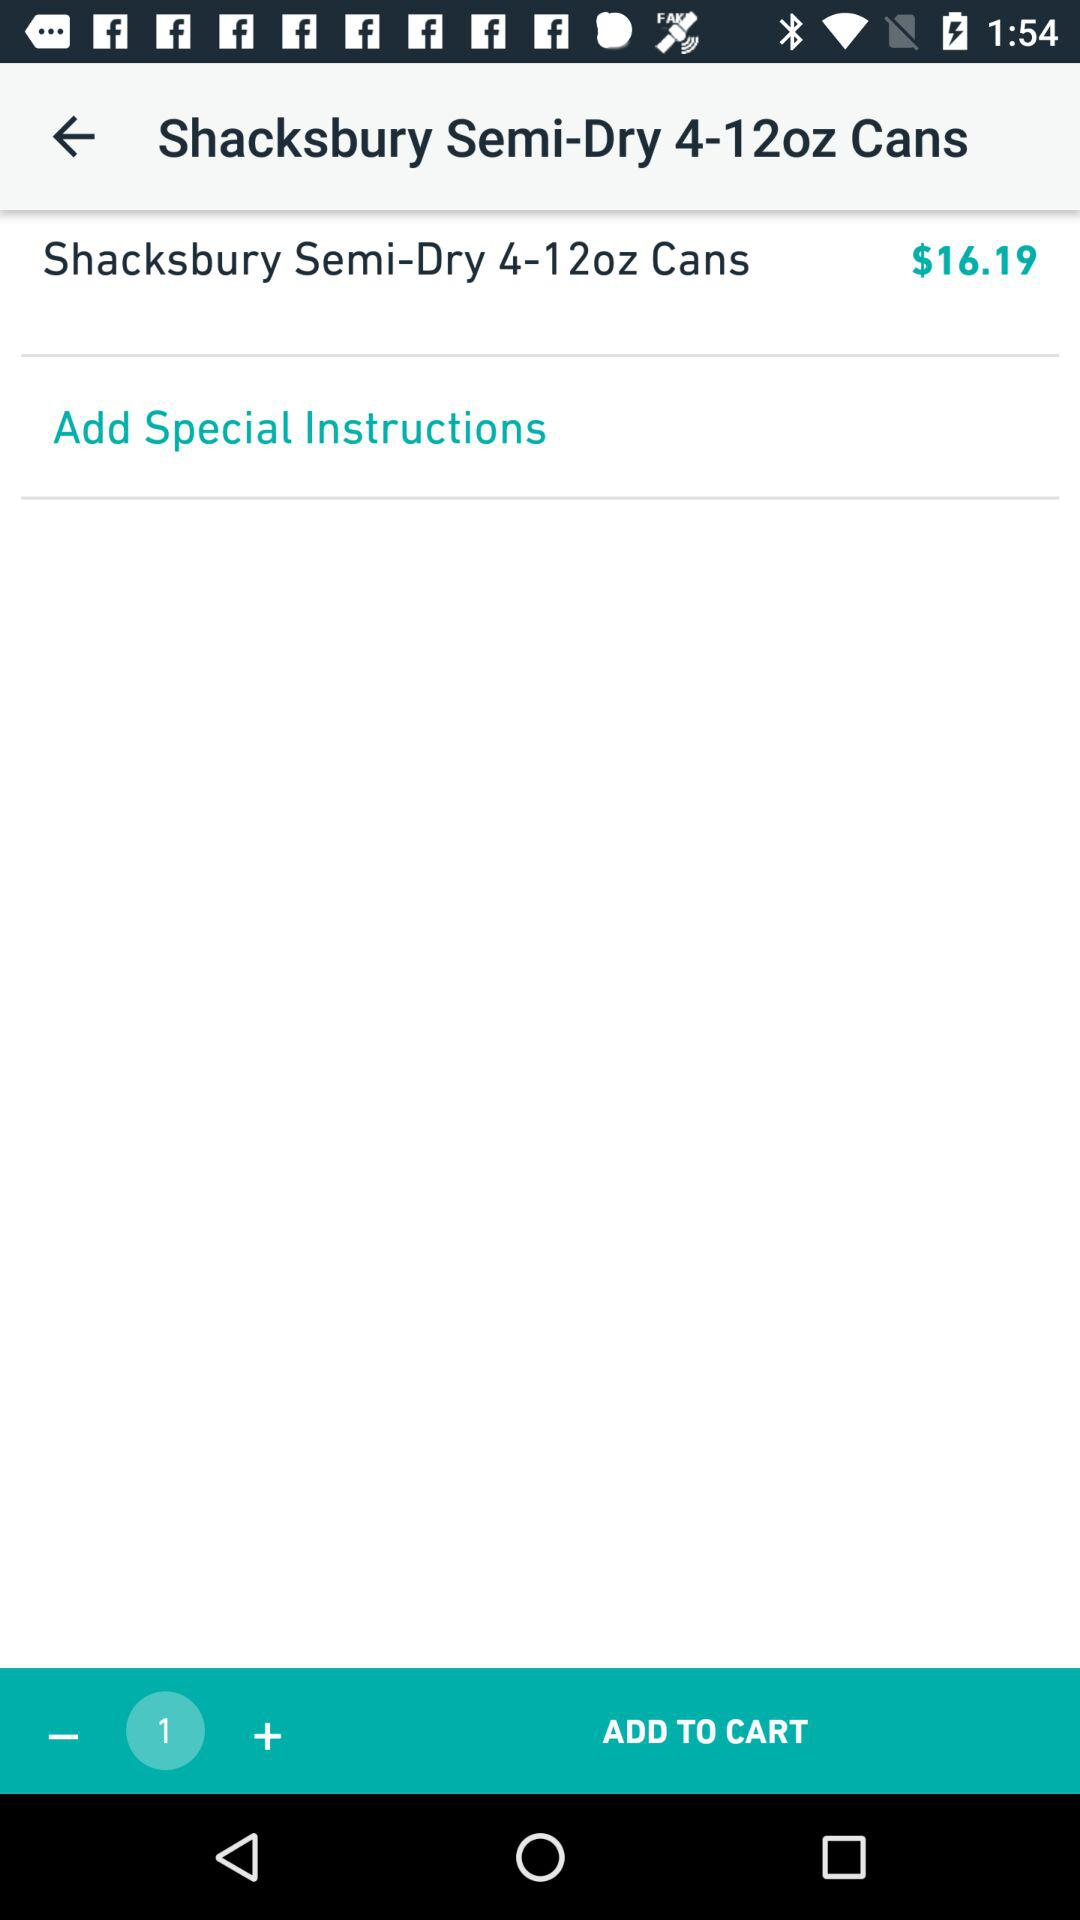What is the total price of the items in the cart?
Answer the question using a single word or phrase. $16.19 